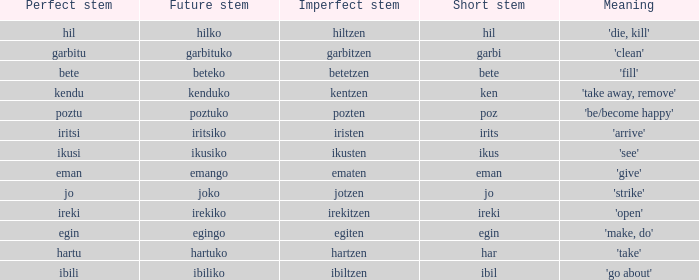Name the perfect stem for jo 1.0. 